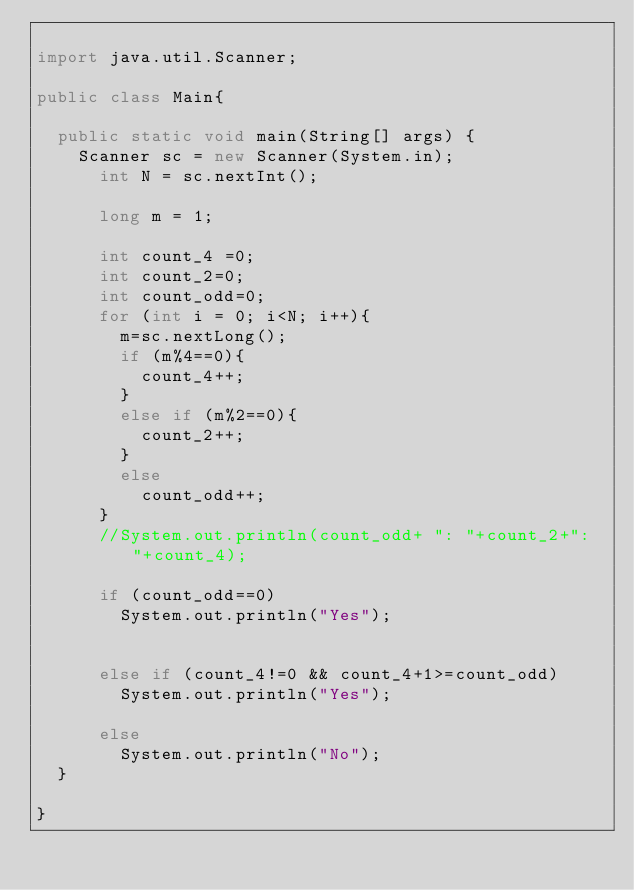<code> <loc_0><loc_0><loc_500><loc_500><_Java_>
import java.util.Scanner;

public class Main{

	public static void main(String[] args) {
		Scanner sc = new Scanner(System.in);
	    int N = sc.nextInt();
	    
	    long m = 1;
	   
	    int count_4 =0;
	    int count_2=0;
	    int count_odd=0;
	    for (int i = 0; i<N; i++){
	    	m=sc.nextLong();
	    	if (m%4==0){
	    		count_4++;
	    	}
	    	else if (m%2==0){
	    		count_2++;
	    	}
	    	else 
	    		count_odd++;
	    }
	    //System.out.println(count_odd+ ": "+count_2+": "+count_4);
	    
	    if (count_odd==0)
	    	System.out.println("Yes");
	    
	    
	    else if (count_4!=0 && count_4+1>=count_odd)
	    	System.out.println("Yes");
	    
	    else
	    	System.out.println("No");
	}

}
</code> 